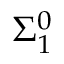<formula> <loc_0><loc_0><loc_500><loc_500>\Sigma _ { 1 } ^ { 0 }</formula> 